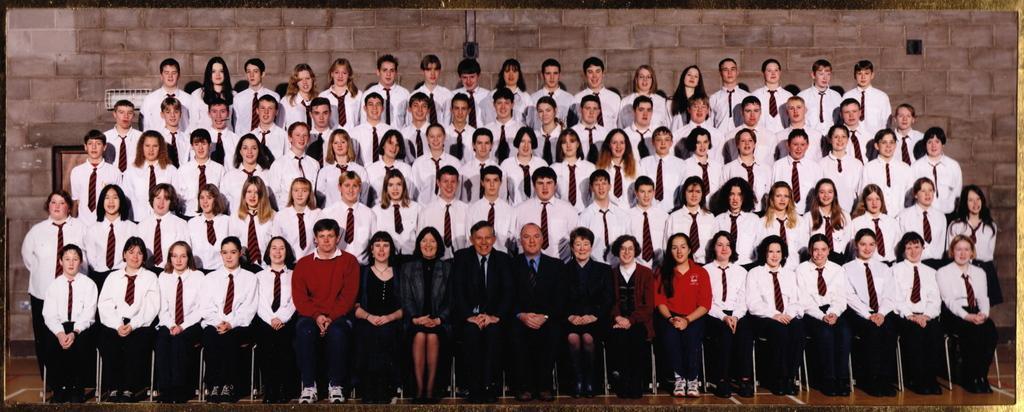How would you summarize this image in a sentence or two? In this image I see number of people in which most of them are wearing same dress and these 2 men are wearing suits and I see that these people are sitting on chairs and rest of them are standing and in the background I see the wall. 